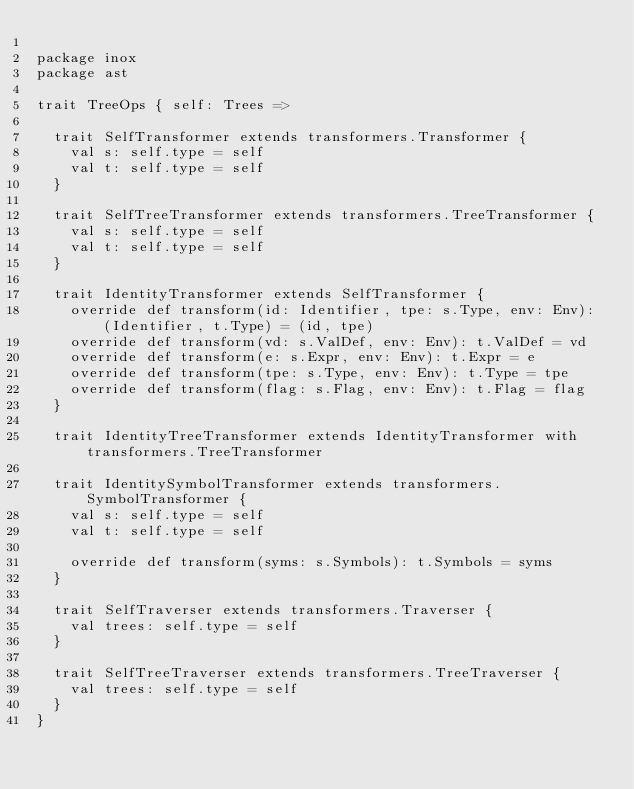Convert code to text. <code><loc_0><loc_0><loc_500><loc_500><_Scala_>
package inox
package ast

trait TreeOps { self: Trees =>

  trait SelfTransformer extends transformers.Transformer {
    val s: self.type = self
    val t: self.type = self
  }

  trait SelfTreeTransformer extends transformers.TreeTransformer {
    val s: self.type = self
    val t: self.type = self
  }

  trait IdentityTransformer extends SelfTransformer {
    override def transform(id: Identifier, tpe: s.Type, env: Env): (Identifier, t.Type) = (id, tpe)
    override def transform(vd: s.ValDef, env: Env): t.ValDef = vd
    override def transform(e: s.Expr, env: Env): t.Expr = e
    override def transform(tpe: s.Type, env: Env): t.Type = tpe
    override def transform(flag: s.Flag, env: Env): t.Flag = flag
  }

  trait IdentityTreeTransformer extends IdentityTransformer with transformers.TreeTransformer

  trait IdentitySymbolTransformer extends transformers.SymbolTransformer {
    val s: self.type = self
    val t: self.type = self

    override def transform(syms: s.Symbols): t.Symbols = syms
  }

  trait SelfTraverser extends transformers.Traverser {
    val trees: self.type = self
  }

  trait SelfTreeTraverser extends transformers.TreeTraverser {
    val trees: self.type = self
  }
}
</code> 